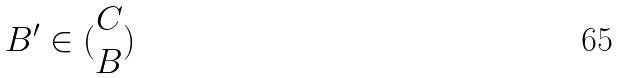<formula> <loc_0><loc_0><loc_500><loc_500>B ^ { \prime } \in ( \begin{matrix} C \\ B \end{matrix} )</formula> 